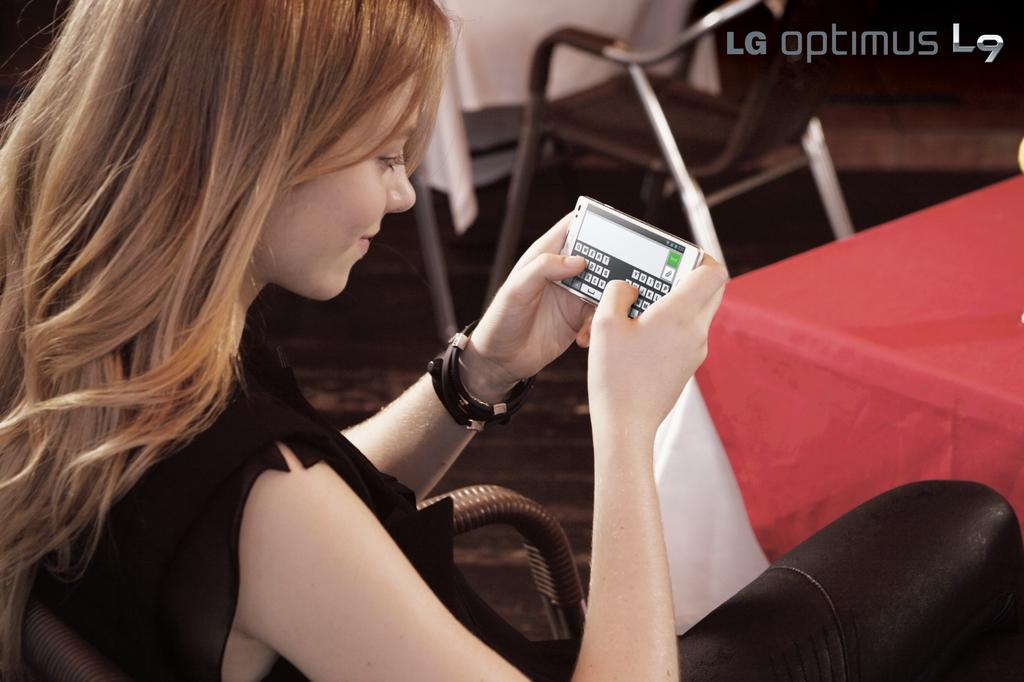Who is the main subject in the image? There is a lady in the image. What is the lady wearing? The lady is wearing a black dress. What is the lady doing in the image? The lady is sitting on a chair. What object is the lady holding? The lady is holding a mobile phone. What is on the table in front of the lady? The table has a red cloth on it. Are there any other chairs visible in the image? Yes, there is another chair visible in the top corner of the image. What type of parcel is being delivered to the lady in the image? There is no parcel visible in the image. Is the lady having a discussion with someone on her mobile phone in the image? The image does not show any indication of a discussion taking place, only the lady holding a mobile phone. 